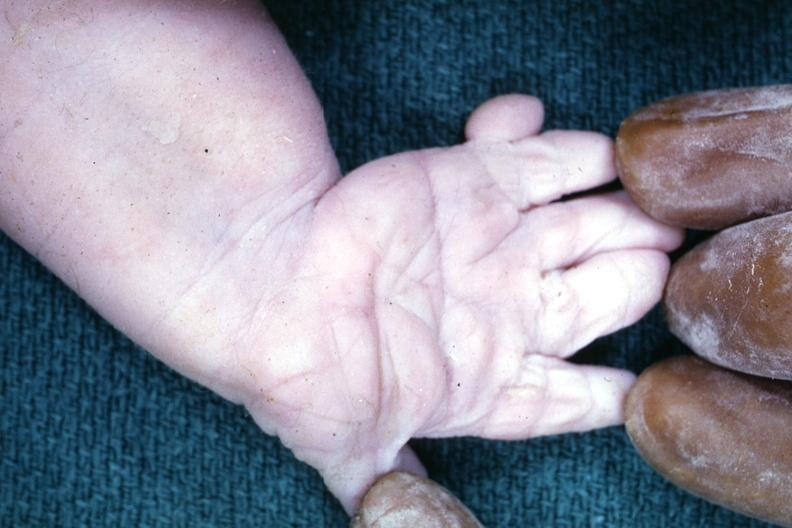re extremities present?
Answer the question using a single word or phrase. Yes 